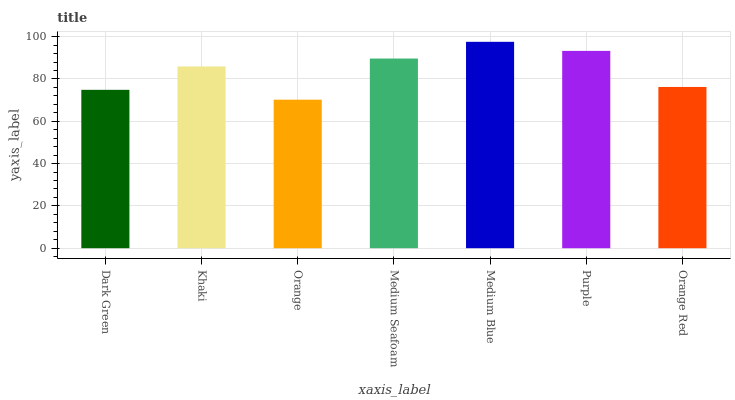Is Orange the minimum?
Answer yes or no. Yes. Is Medium Blue the maximum?
Answer yes or no. Yes. Is Khaki the minimum?
Answer yes or no. No. Is Khaki the maximum?
Answer yes or no. No. Is Khaki greater than Dark Green?
Answer yes or no. Yes. Is Dark Green less than Khaki?
Answer yes or no. Yes. Is Dark Green greater than Khaki?
Answer yes or no. No. Is Khaki less than Dark Green?
Answer yes or no. No. Is Khaki the high median?
Answer yes or no. Yes. Is Khaki the low median?
Answer yes or no. Yes. Is Purple the high median?
Answer yes or no. No. Is Orange the low median?
Answer yes or no. No. 